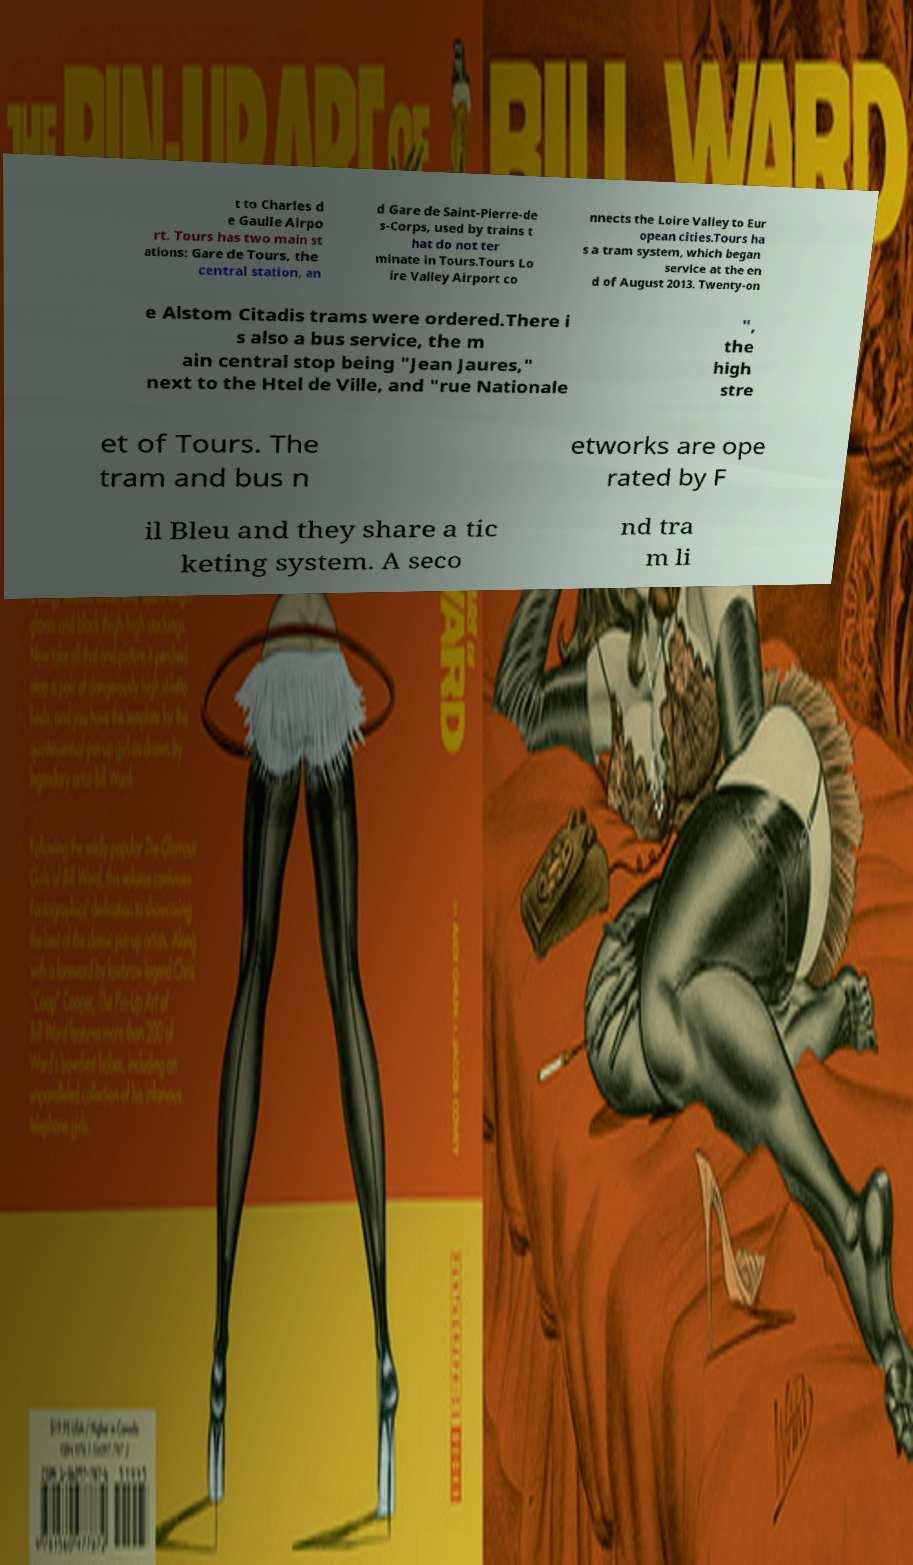For documentation purposes, I need the text within this image transcribed. Could you provide that? t to Charles d e Gaulle Airpo rt. Tours has two main st ations: Gare de Tours, the central station, an d Gare de Saint-Pierre-de s-Corps, used by trains t hat do not ter minate in Tours.Tours Lo ire Valley Airport co nnects the Loire Valley to Eur opean cities.Tours ha s a tram system, which began service at the en d of August 2013. Twenty-on e Alstom Citadis trams were ordered.There i s also a bus service, the m ain central stop being "Jean Jaures," next to the Htel de Ville, and "rue Nationale ", the high stre et of Tours. The tram and bus n etworks are ope rated by F il Bleu and they share a tic keting system. A seco nd tra m li 